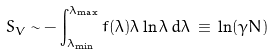Convert formula to latex. <formula><loc_0><loc_0><loc_500><loc_500>S _ { V } \sim - \int _ { \lambda _ { \min } } ^ { \lambda _ { \max } } f ( \lambda ) \lambda \ln \lambda \, d \lambda \, \equiv \, \ln ( \gamma N )</formula> 